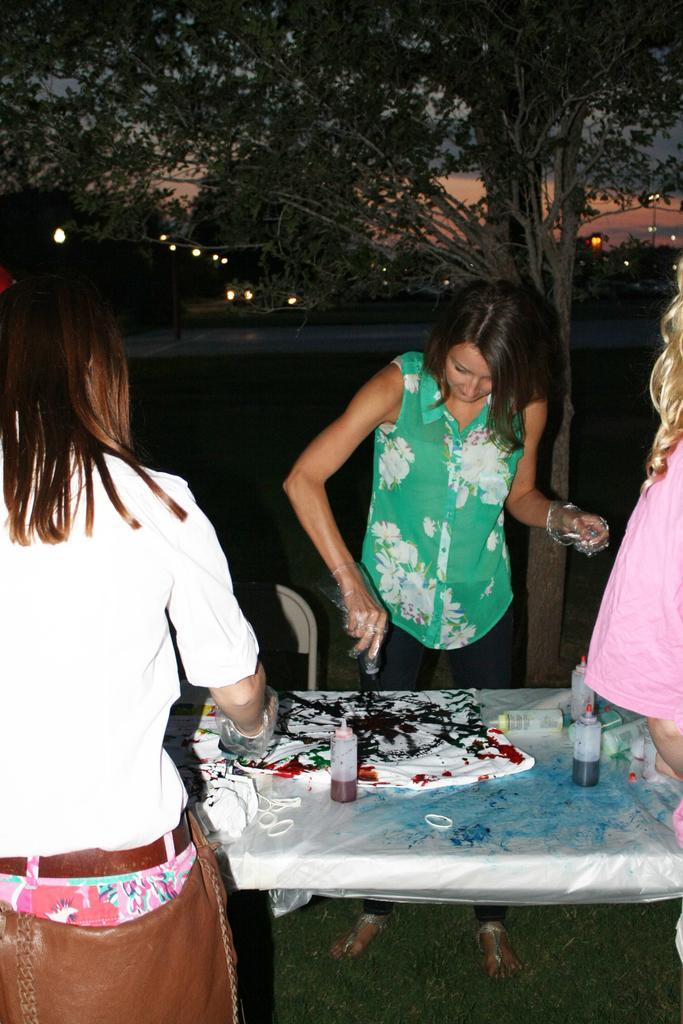In one or two sentences, can you explain what this image depicts? In this image we can see a woman wearing green dress is stunning. There are few bottles with colors and t shirt on the table. In the background we can see a tree. 